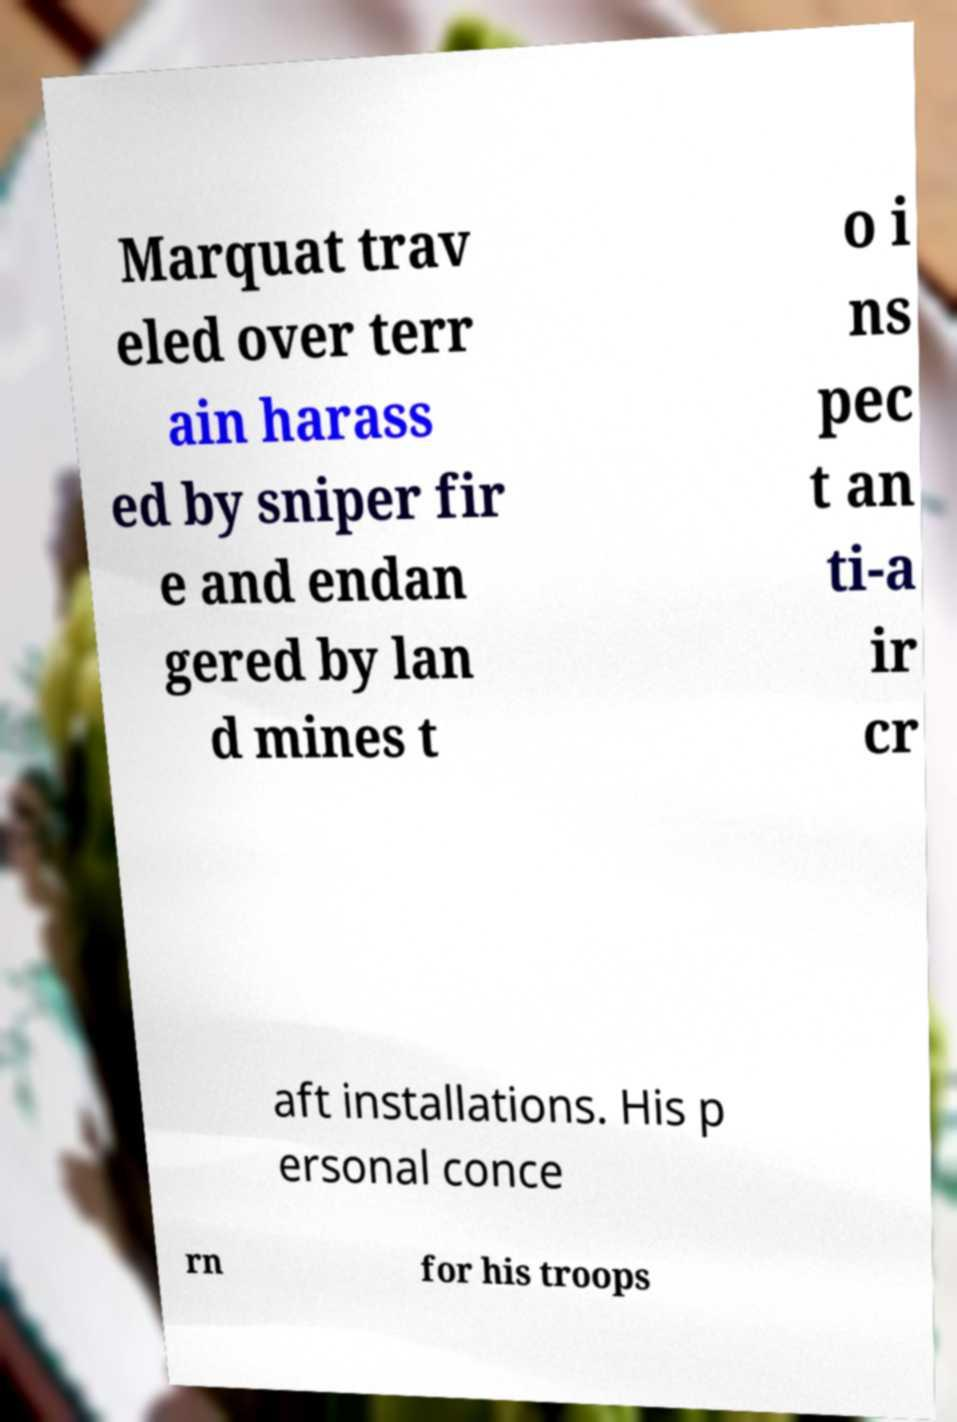Can you read and provide the text displayed in the image?This photo seems to have some interesting text. Can you extract and type it out for me? Marquat trav eled over terr ain harass ed by sniper fir e and endan gered by lan d mines t o i ns pec t an ti-a ir cr aft installations. His p ersonal conce rn for his troops 